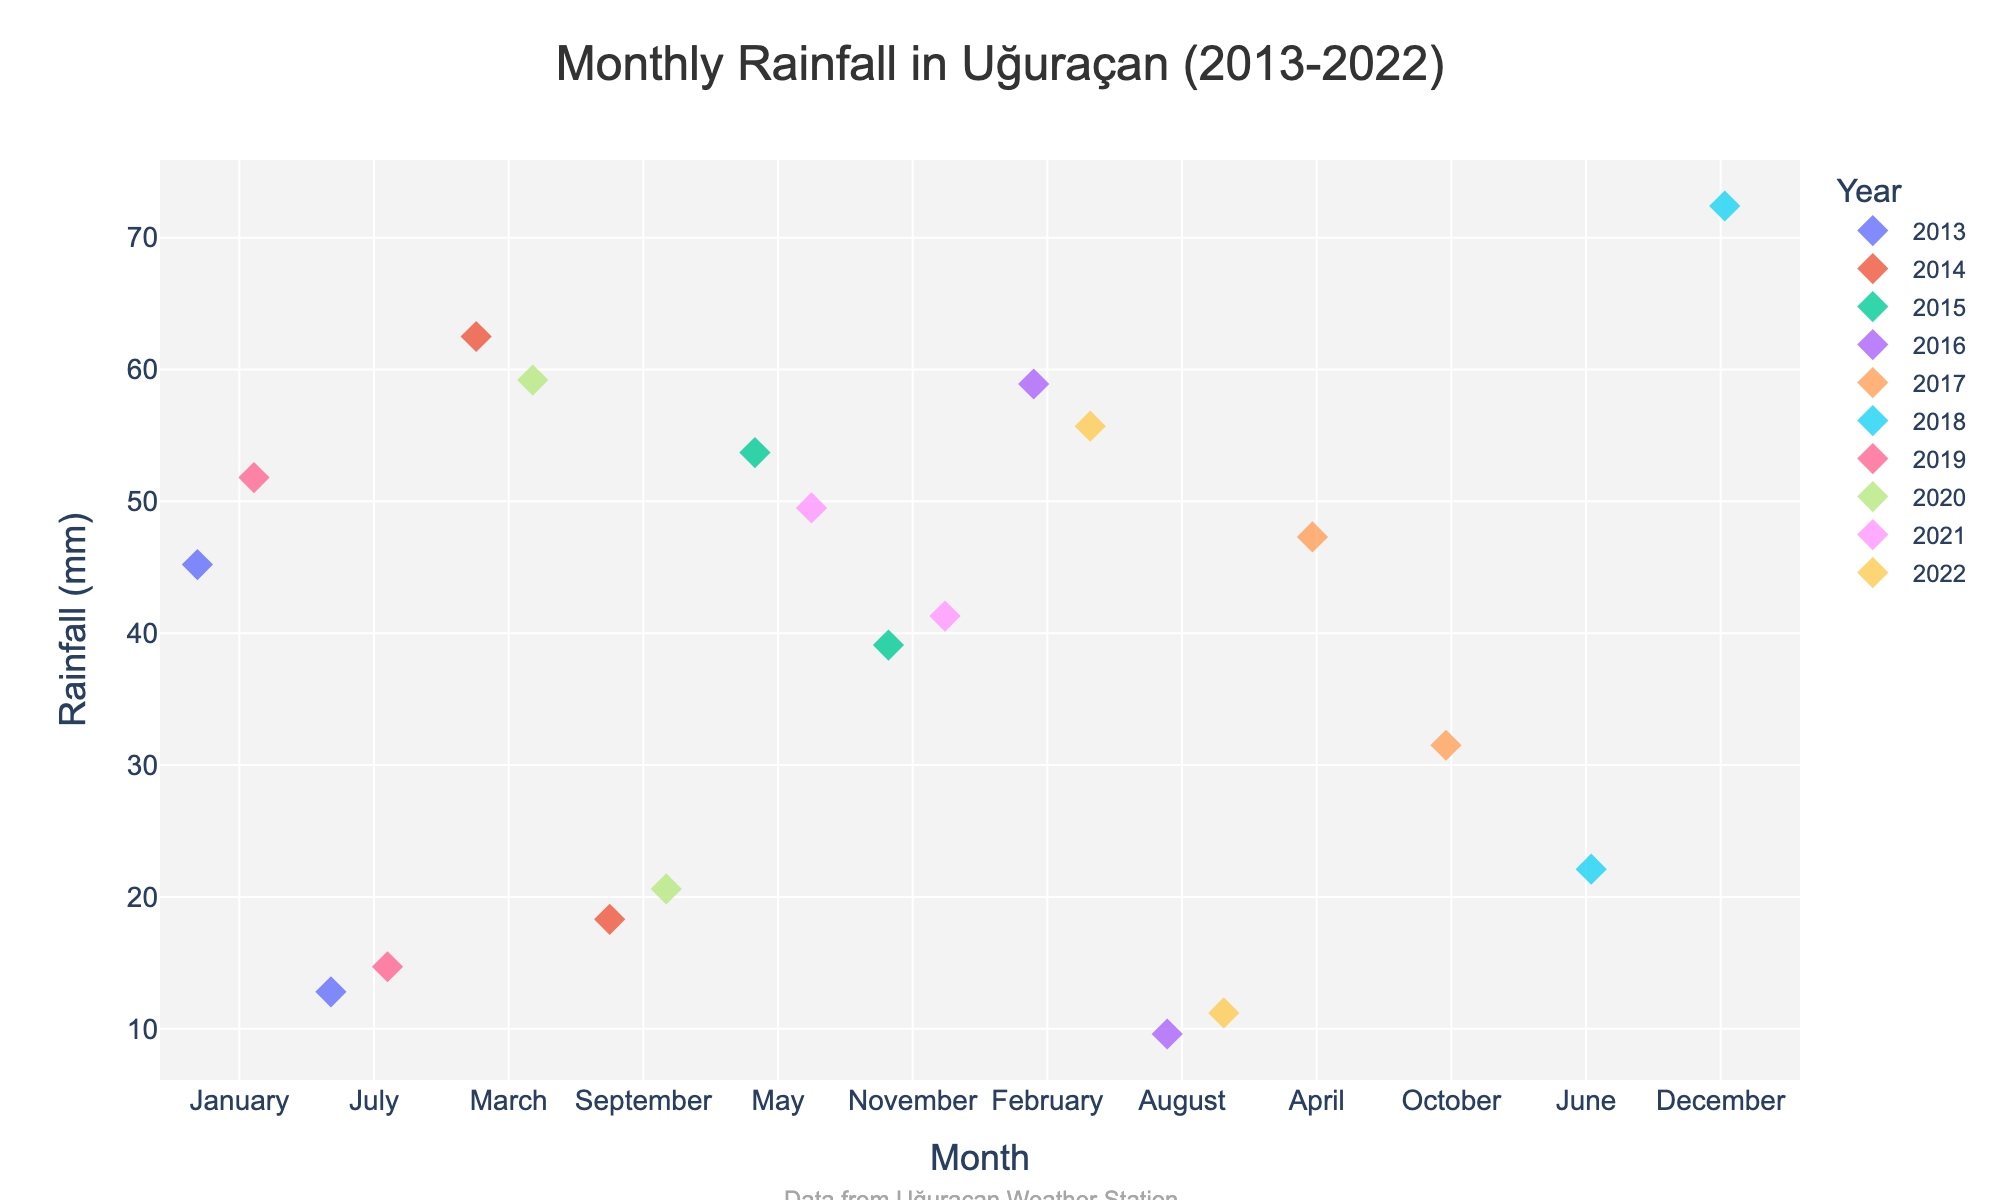How many years of data are shown in the plot? Count the unique years represented by different colors. The title indicates data from 2013 to 2022, inclusive.
Answer: 10 Which month has the highest recorded rainfall in a single year? Look for the month with the highest point on the y-axis. December 2018 has the highest recorded rainfall with approximately 72.4 mm.
Answer: December In which year did August have the lowest rainfall? Identify the data points for August and compare rainfall amounts. August 2016 shows the lowest rainfall with 9.6 mm.
Answer: 2016 How does the rainfall in March 2014 compare to March 2020? Locate the data points for March 2014 and March 2020. Compare their y-axis values. March 2014 has 62.5 mm, and March 2020 has 59.2 mm.
Answer: March 2014 has more rainfall What is the average rainfall in January across all years? Calculate the average of the January data points: (45.2 + 51.8) / 2 = 48.5 mm.
Answer: 48.5 mm Which year faced the highest rainfall in November and what was the value? Compare the November points across different years. November 2021 has the highest rainfall with 41.3 mm.
Answer: 2021, 41.3 mm Are there any months where rainfall consistently stays below 20 mm? Check if all data points for any month fall below 20 mm. Both July and August consistently have all points below 20 mm.
Answer: July and August What's the median rainfall value for the months of February across all years? List the February rainfall values (58.9, 55.7), and the median is the middle value. Since there are only two values, the median is (58.9 + 55.7) / 2 = 57.3 mm.
Answer: 57.3 mm Which month shows the most variability in rainfall amounts and why? Assess the spread of data points along the y-axis for each month. March shows a considerable range from around 59.2 mm to 62.5 mm, indicating high variability.
Answer: March 